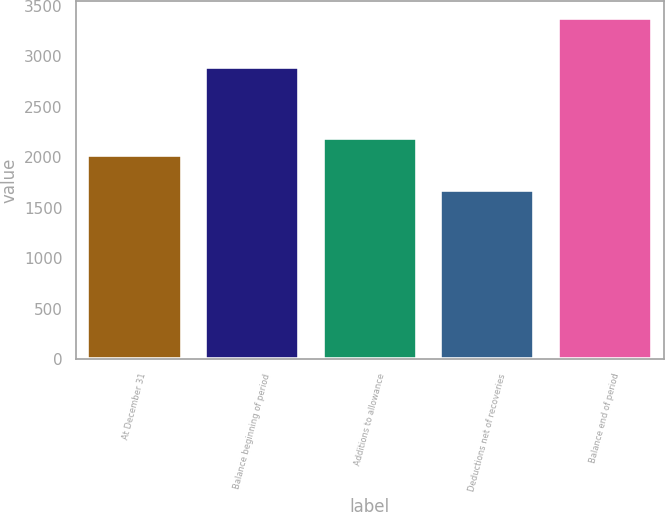Convert chart to OTSL. <chart><loc_0><loc_0><loc_500><loc_500><bar_chart><fcel>At December 31<fcel>Balance beginning of period<fcel>Additions to allowance<fcel>Deductions net of recoveries<fcel>Balance end of period<nl><fcel>2018<fcel>2892<fcel>2188.9<fcel>1672<fcel>3381<nl></chart> 